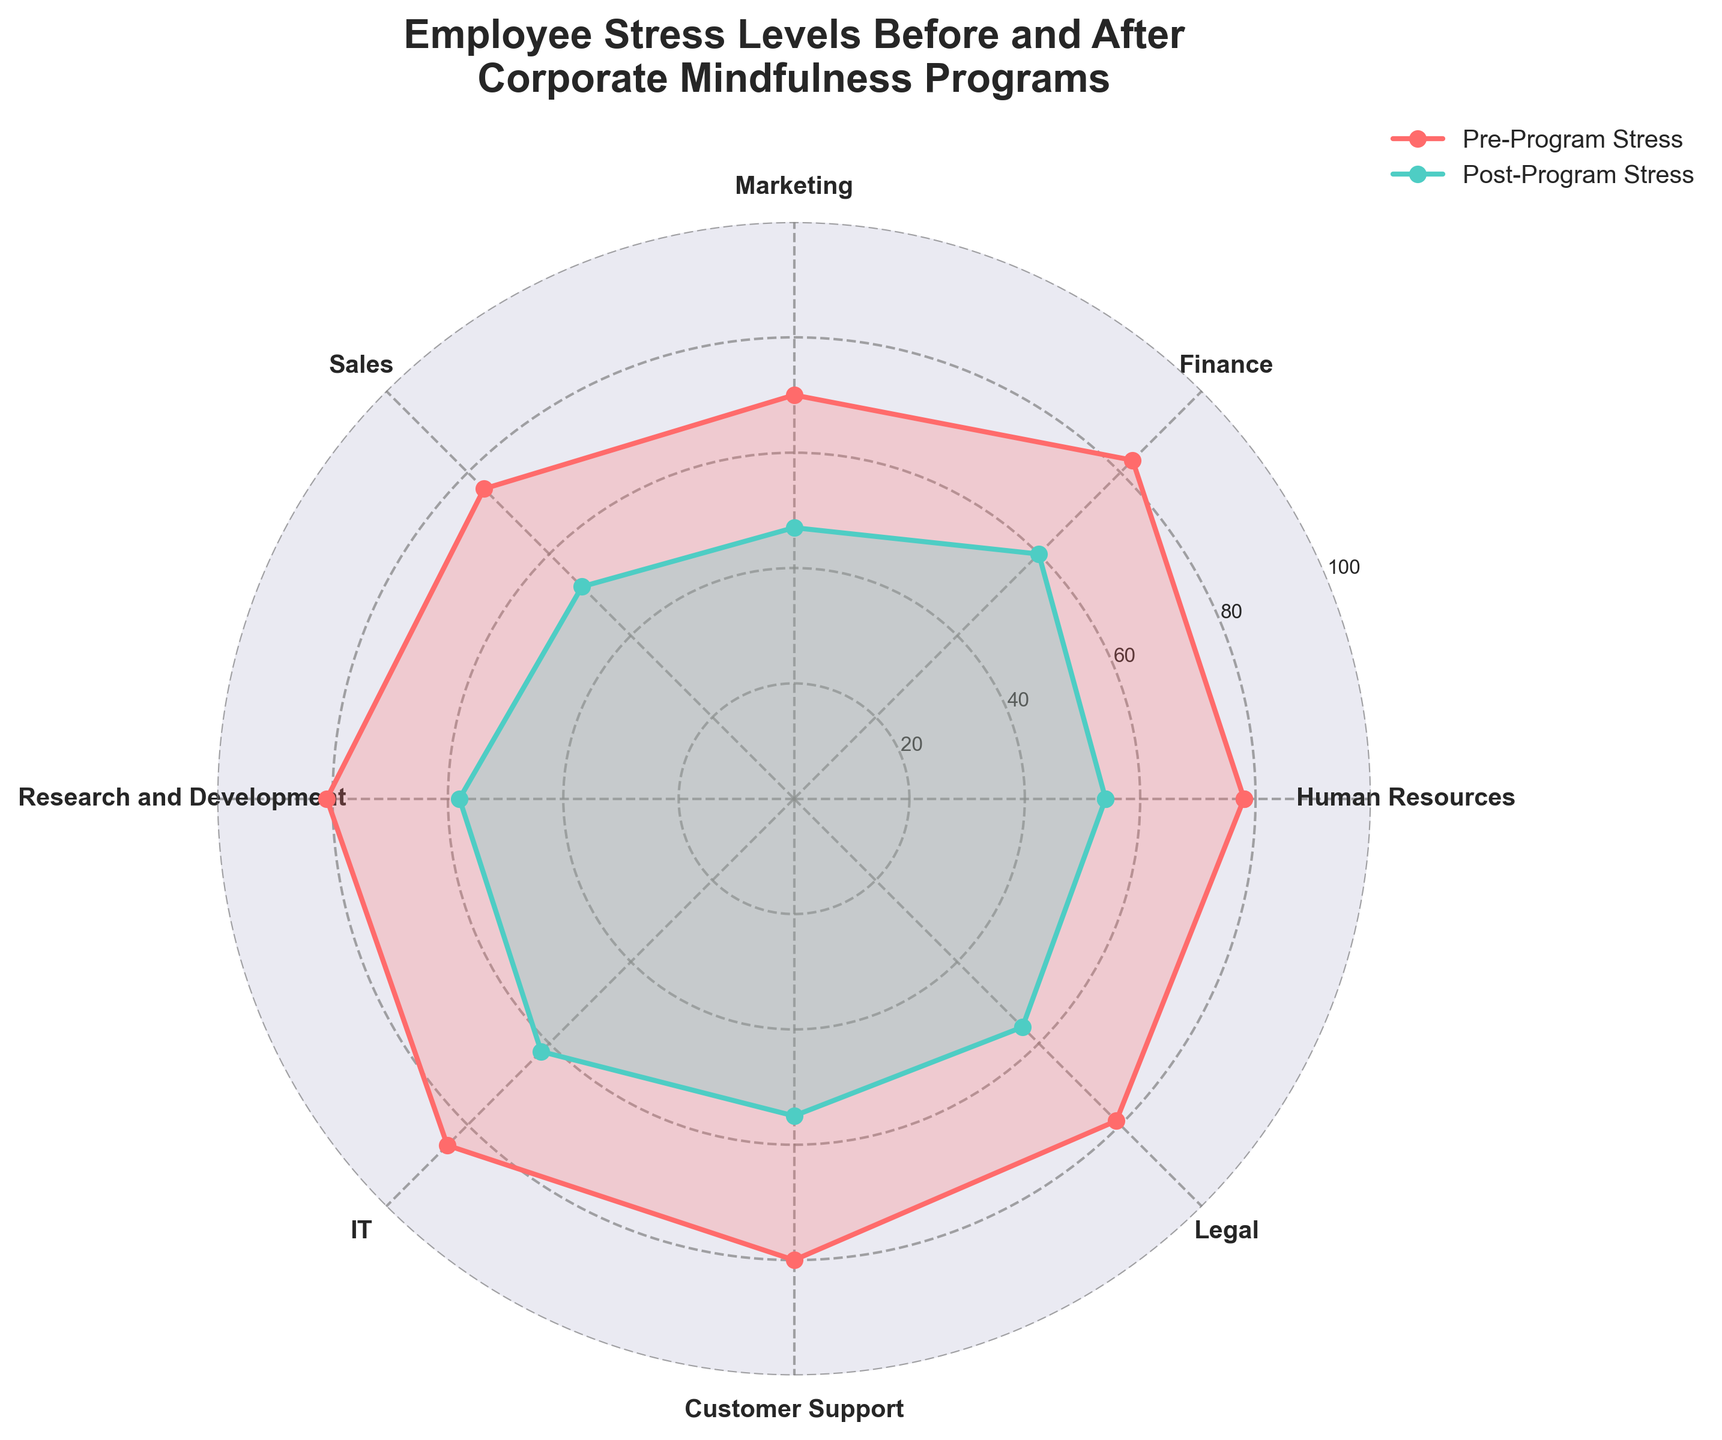What is the title of the polar chart? The title is usually situated at the top of the chart. In this case, it reads "Employee Stress Levels Before and After Corporate Mindfulness Programs".
Answer: Employee Stress Levels Before and After Corporate Mindfulness Programs Which department had the highest pre-program stress level? Look at the points labeled for each department corresponding to pre-program stress levels. The highest point belongs to the IT department.
Answer: IT How much did the stress level decrease for the Human Resources department after the mindfulness program? The pre-program stress level for Human Resources is 78, and the post-program stress level is 54. The difference is 78 - 54.
Answer: 24 Which department saw the largest reduction in stress levels after the mindfulness program? To find this, subtract the post-program stress levels from the pre-program stress levels for each department and identify the maximum difference. Marketing had a reduction from 70 to 47, which is the largest at 23 units.
Answer: Marketing What is the average post-program stress level across all departments? Sum the post-program stress levels (54 + 60 + 47 + 52 + 58 + 62 + 55 + 56) and divide by the number of departments (8). The calculation is (54 + 60 + 47 + 52 + 58 + 62 + 55 + 56) / 8.
Answer: 55.5 Which department shows a post-program stress level closest to the average post-program stress level? First, find the average post-program stress level which is 55.5. Then, compare this to each department's post-program stress level to determine the closest value. Human Resources with a post-program stress level of 54 is closest.
Answer: Human Resources Is there any department where the post-program stress level is higher than 60? Check the post-program stress levels of all departments to see if any exceed 60. The IT department has a post-program stress level of 62.
Answer: Yes, IT Which department had the smallest reduction in stress levels after the mindfulness program? Calculate the difference between pre- and post-program stress levels for all departments and identify the smallest difference. The IT department had a reduction from 85 to 62, which is 23 units.
Answer: IT What are the colors used to represent pre-program and post-program stress levels on the polar chart? The colors representing pre-program and post-program stress levels can be identified from the legend. The pre-program stress is shown in red, and the post-program stress is shown in green.
Answer: Red for pre-program, Green for post-program 